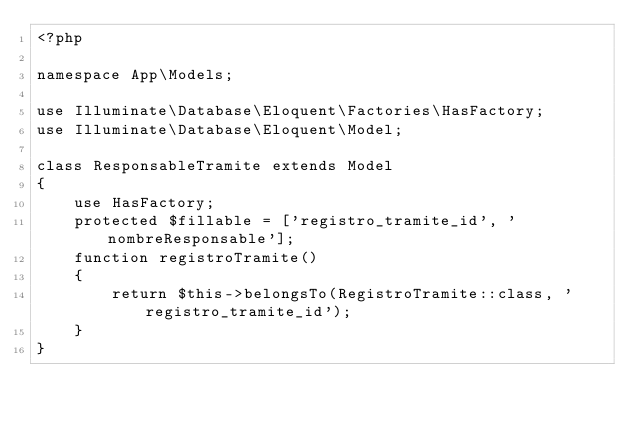Convert code to text. <code><loc_0><loc_0><loc_500><loc_500><_PHP_><?php

namespace App\Models;

use Illuminate\Database\Eloquent\Factories\HasFactory;
use Illuminate\Database\Eloquent\Model;

class ResponsableTramite extends Model
{
    use HasFactory;
    protected $fillable = ['registro_tramite_id', 'nombreResponsable'];
    function registroTramite()
    {
        return $this->belongsTo(RegistroTramite::class, 'registro_tramite_id');
    }
}
</code> 